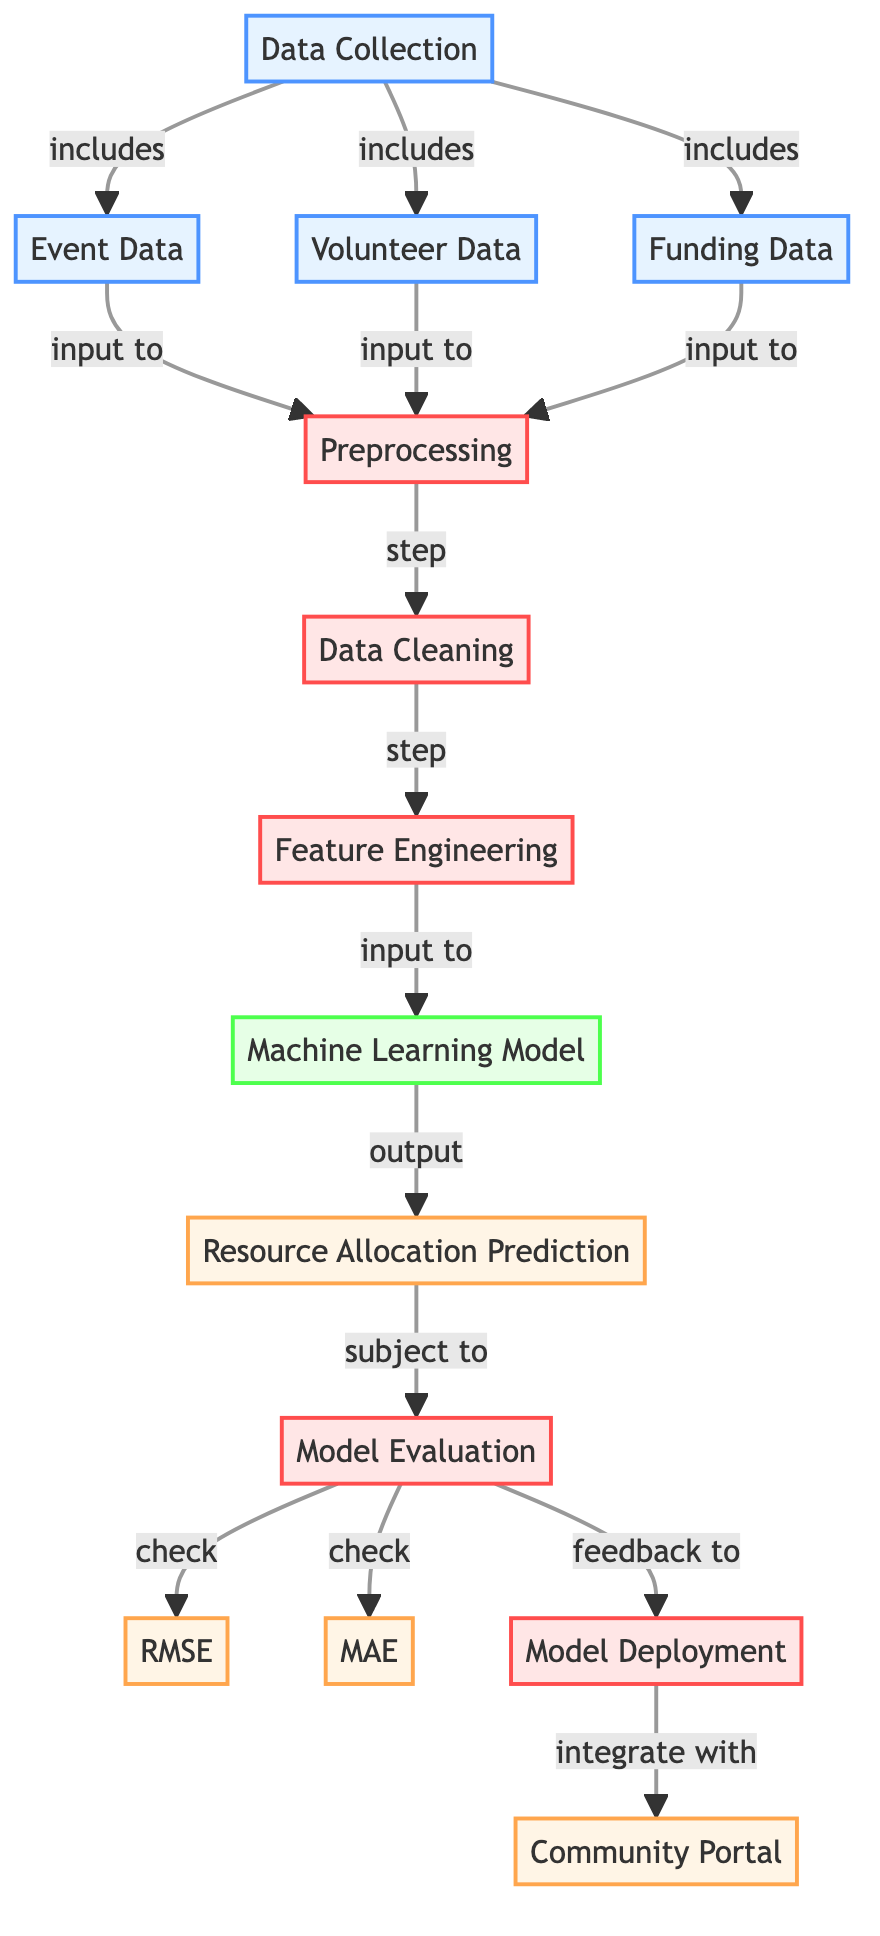What are the three types of data collected? The diagram indicates that three types of data are collected: Event Data, Volunteer Data, and Funding Data. These are shown as three nodes that connect directly to the Data Collection node.
Answer: Event Data, Volunteer Data, Funding Data What comes after Data Cleaning? The diagram shows that after the Data Cleaning process, the next step is Feature Engineering, which is indicated by the arrow pointing from the cleaning node to the transformation node.
Answer: Feature Engineering What is the output of the Machine Learning model? The diagram states that the output from the Machine Learning Model is Resource Allocation Prediction, which is shown as the immediate output node connected to the ml_model node.
Answer: Resource Allocation Prediction Which evaluation metrics are used? The diagram lists Root Mean Square Error (RMSE) and Mean Absolute Error (MAE) as the evaluation metrics, indicated by the connections from the evaluation node to both output nodes.
Answer: RMSE, MAE What feedback loop is present in this diagram? The diagram includes a feedback loop where the evaluation of the model provides feedback to the deployment process. This indicates a cyclical relationship aimed at improving resource allocation.
Answer: Feedback to deployment How many nodes are involved in the preprocessing stage? There are three nodes involved in the preprocessing stage: cleaning, transformation, and the input nodes (event data, volunteer data, and funding data). While cleaning and transformation are direct processes, the input nodes count as part of this stage leading to the preprocessing node.
Answer: Three What is integrated with the community portal? The diagram indicates that the deployment process is integrated with the Community Portal, which is shown as the final output node connecting from the deployment node.
Answer: Community Portal Which step follows the Model Evaluation? According to the diagram, the step that follows Model Evaluation is Deployment, as there is a direct arrow leading from the evaluation node to the deployment node.
Answer: Model Deployment 